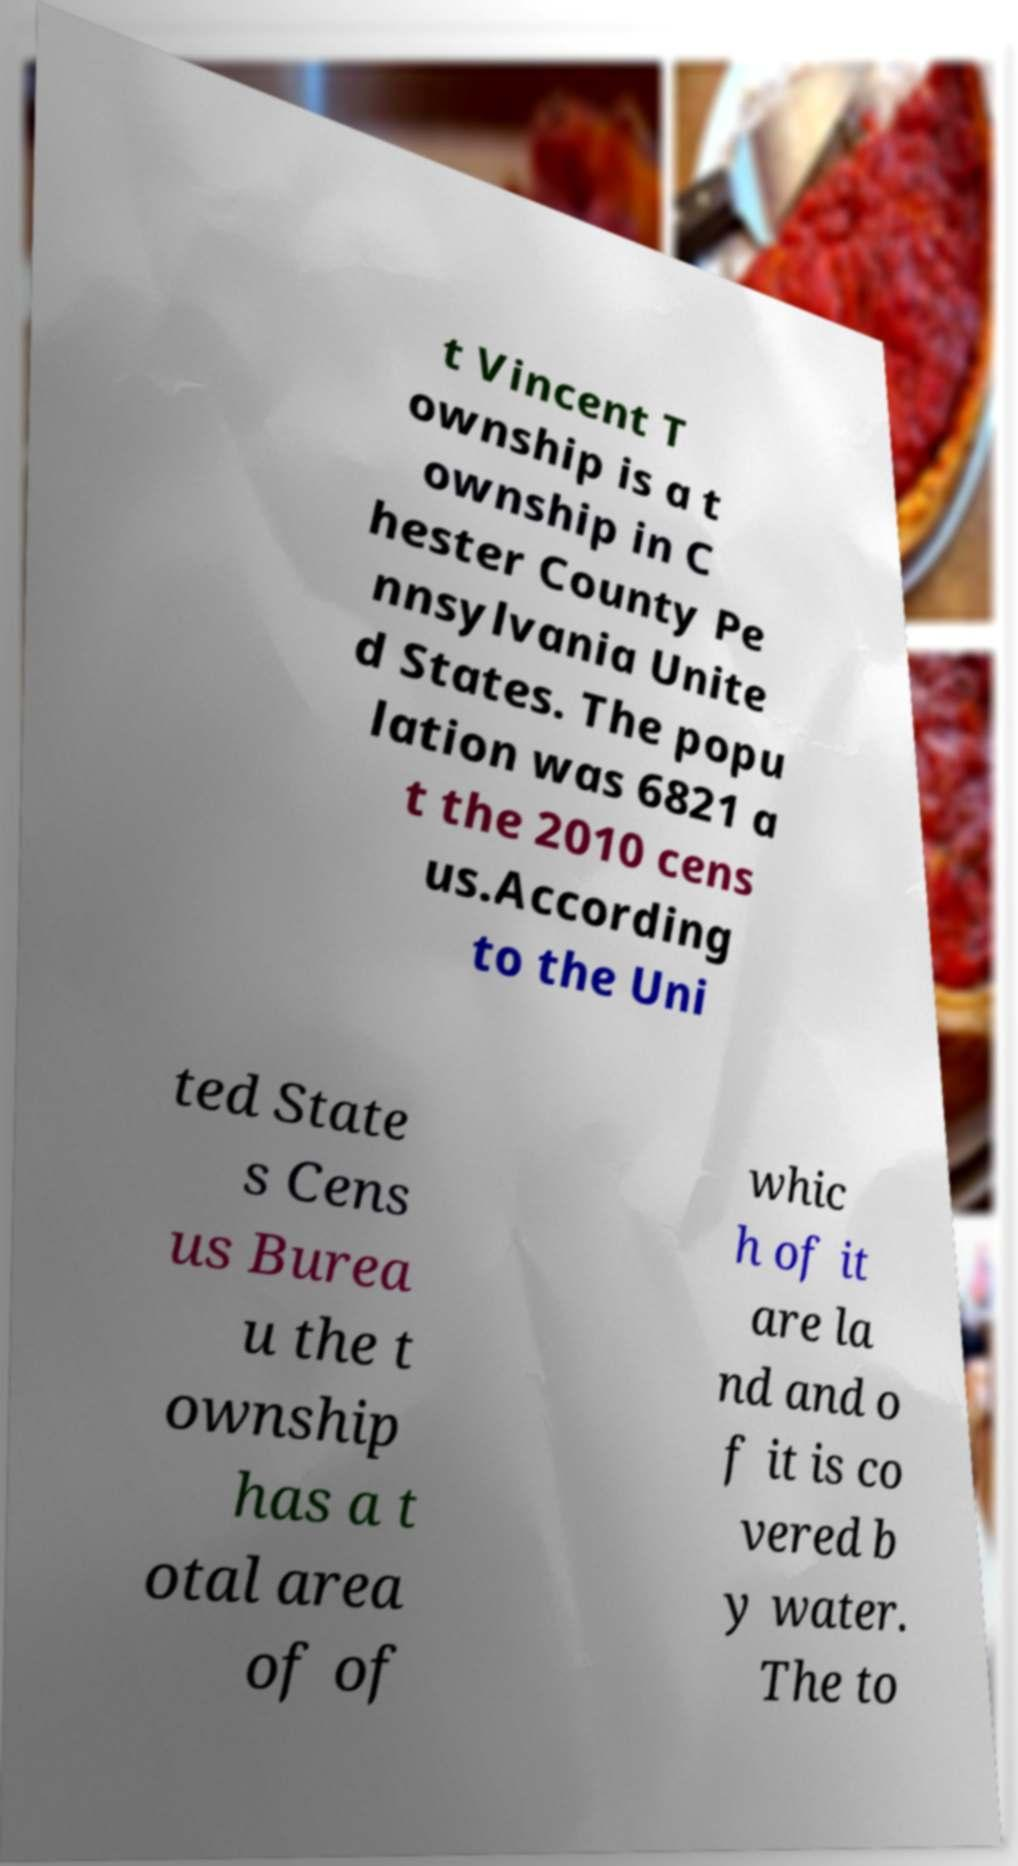Can you accurately transcribe the text from the provided image for me? t Vincent T ownship is a t ownship in C hester County Pe nnsylvania Unite d States. The popu lation was 6821 a t the 2010 cens us.According to the Uni ted State s Cens us Burea u the t ownship has a t otal area of of whic h of it are la nd and o f it is co vered b y water. The to 